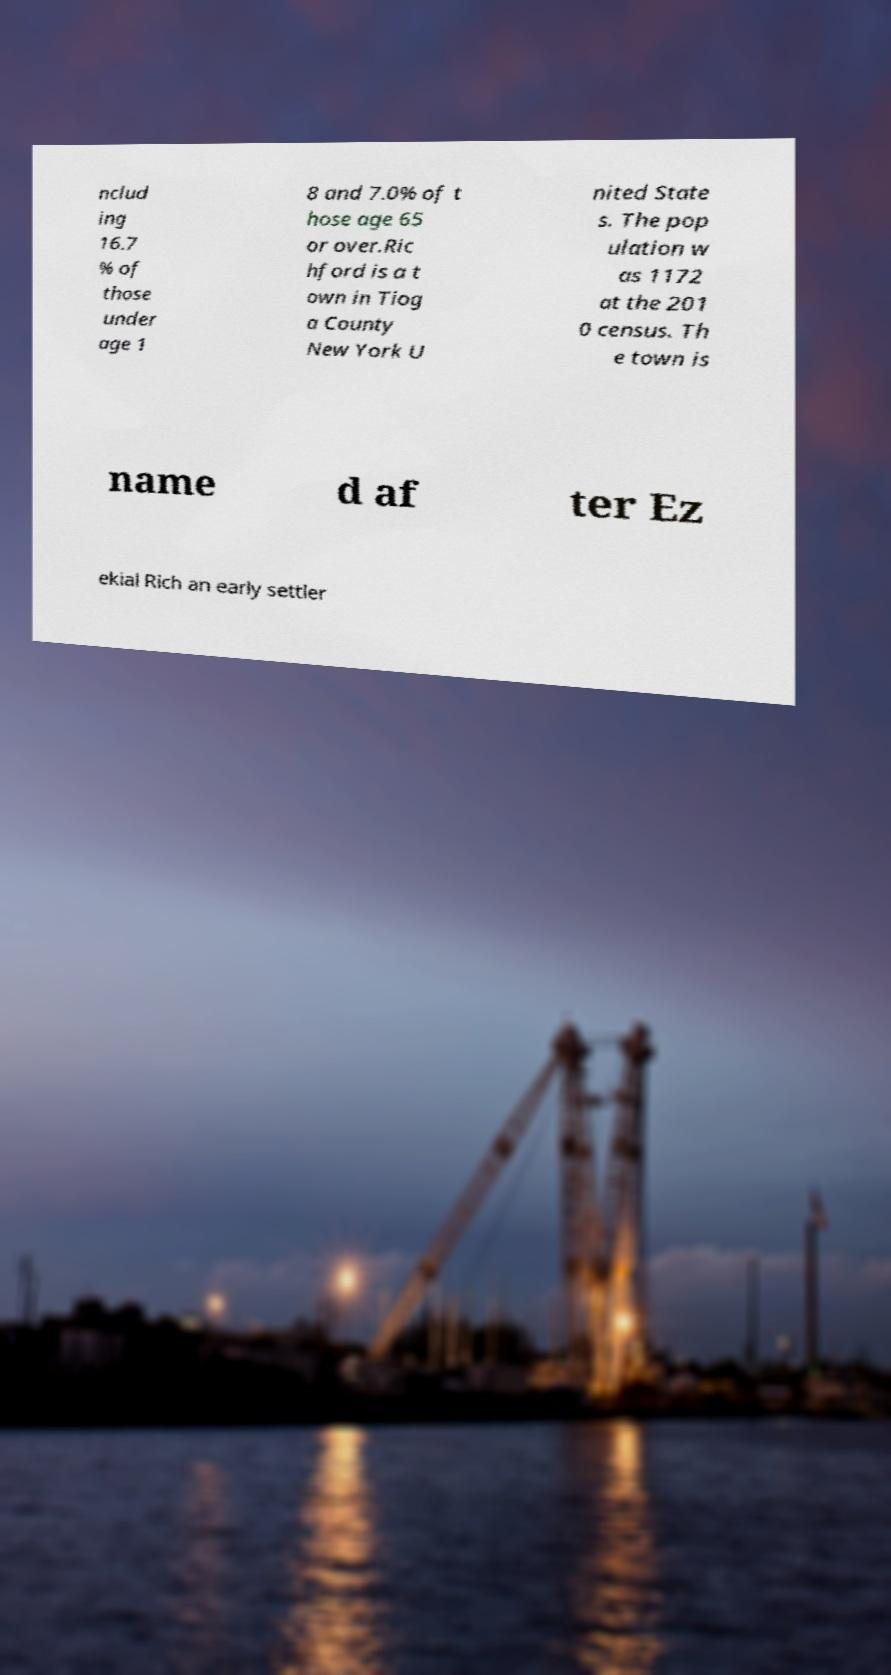Could you assist in decoding the text presented in this image and type it out clearly? nclud ing 16.7 % of those under age 1 8 and 7.0% of t hose age 65 or over.Ric hford is a t own in Tiog a County New York U nited State s. The pop ulation w as 1172 at the 201 0 census. Th e town is name d af ter Ez ekial Rich an early settler 